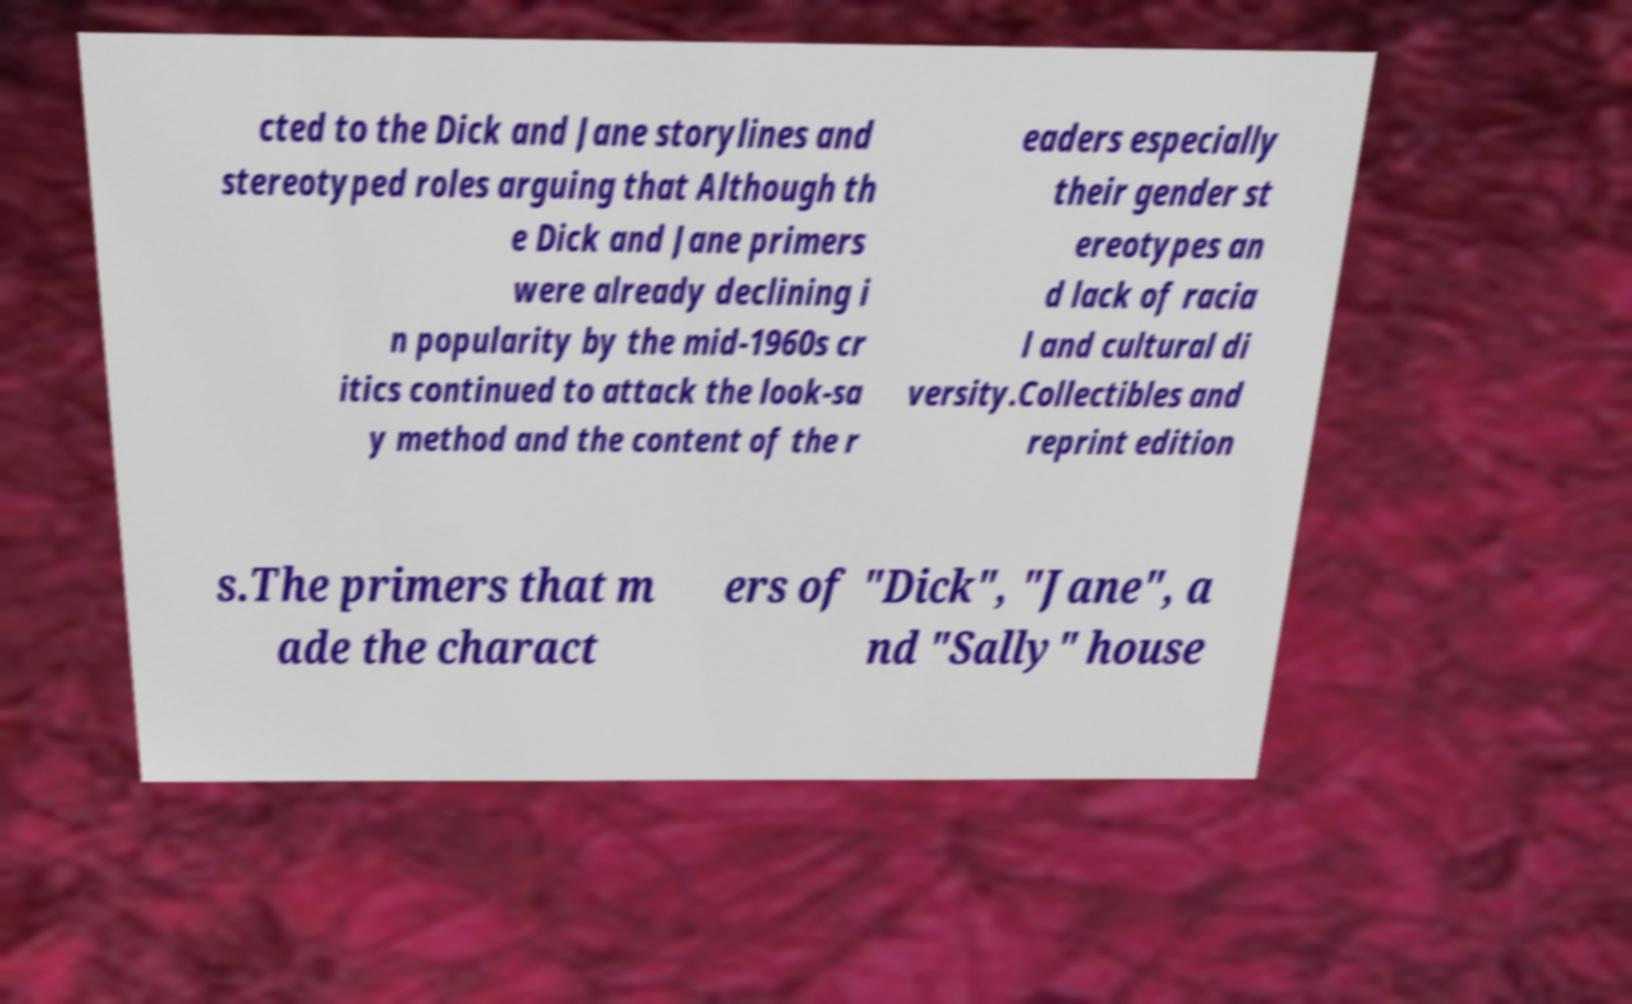Can you read and provide the text displayed in the image?This photo seems to have some interesting text. Can you extract and type it out for me? cted to the Dick and Jane storylines and stereotyped roles arguing that Although th e Dick and Jane primers were already declining i n popularity by the mid-1960s cr itics continued to attack the look-sa y method and the content of the r eaders especially their gender st ereotypes an d lack of racia l and cultural di versity.Collectibles and reprint edition s.The primers that m ade the charact ers of "Dick", "Jane", a nd "Sally" house 